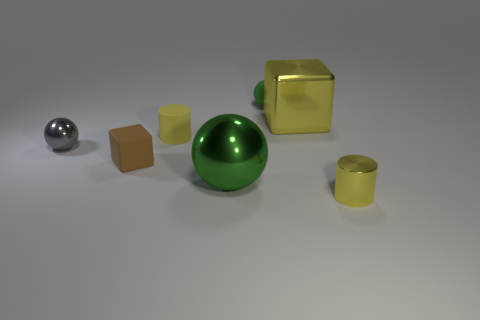Can you describe the shapes and colors of the objects in the image? Certainly! The image features a collection of geometric shapes. There's a large green sphere, a smaller gray sphere, and two cubes - one yellow with a metallic finish and one matte tan. Additionally, there's a yellow cylinder with a reflective surface. What can you tell me about the lighting and shadows in the scene? The lighting in the scene appears to be coming from above, casting soft shadows to the right of the objects. This suggests the light source is not overly harsh and is possibly diffused. 